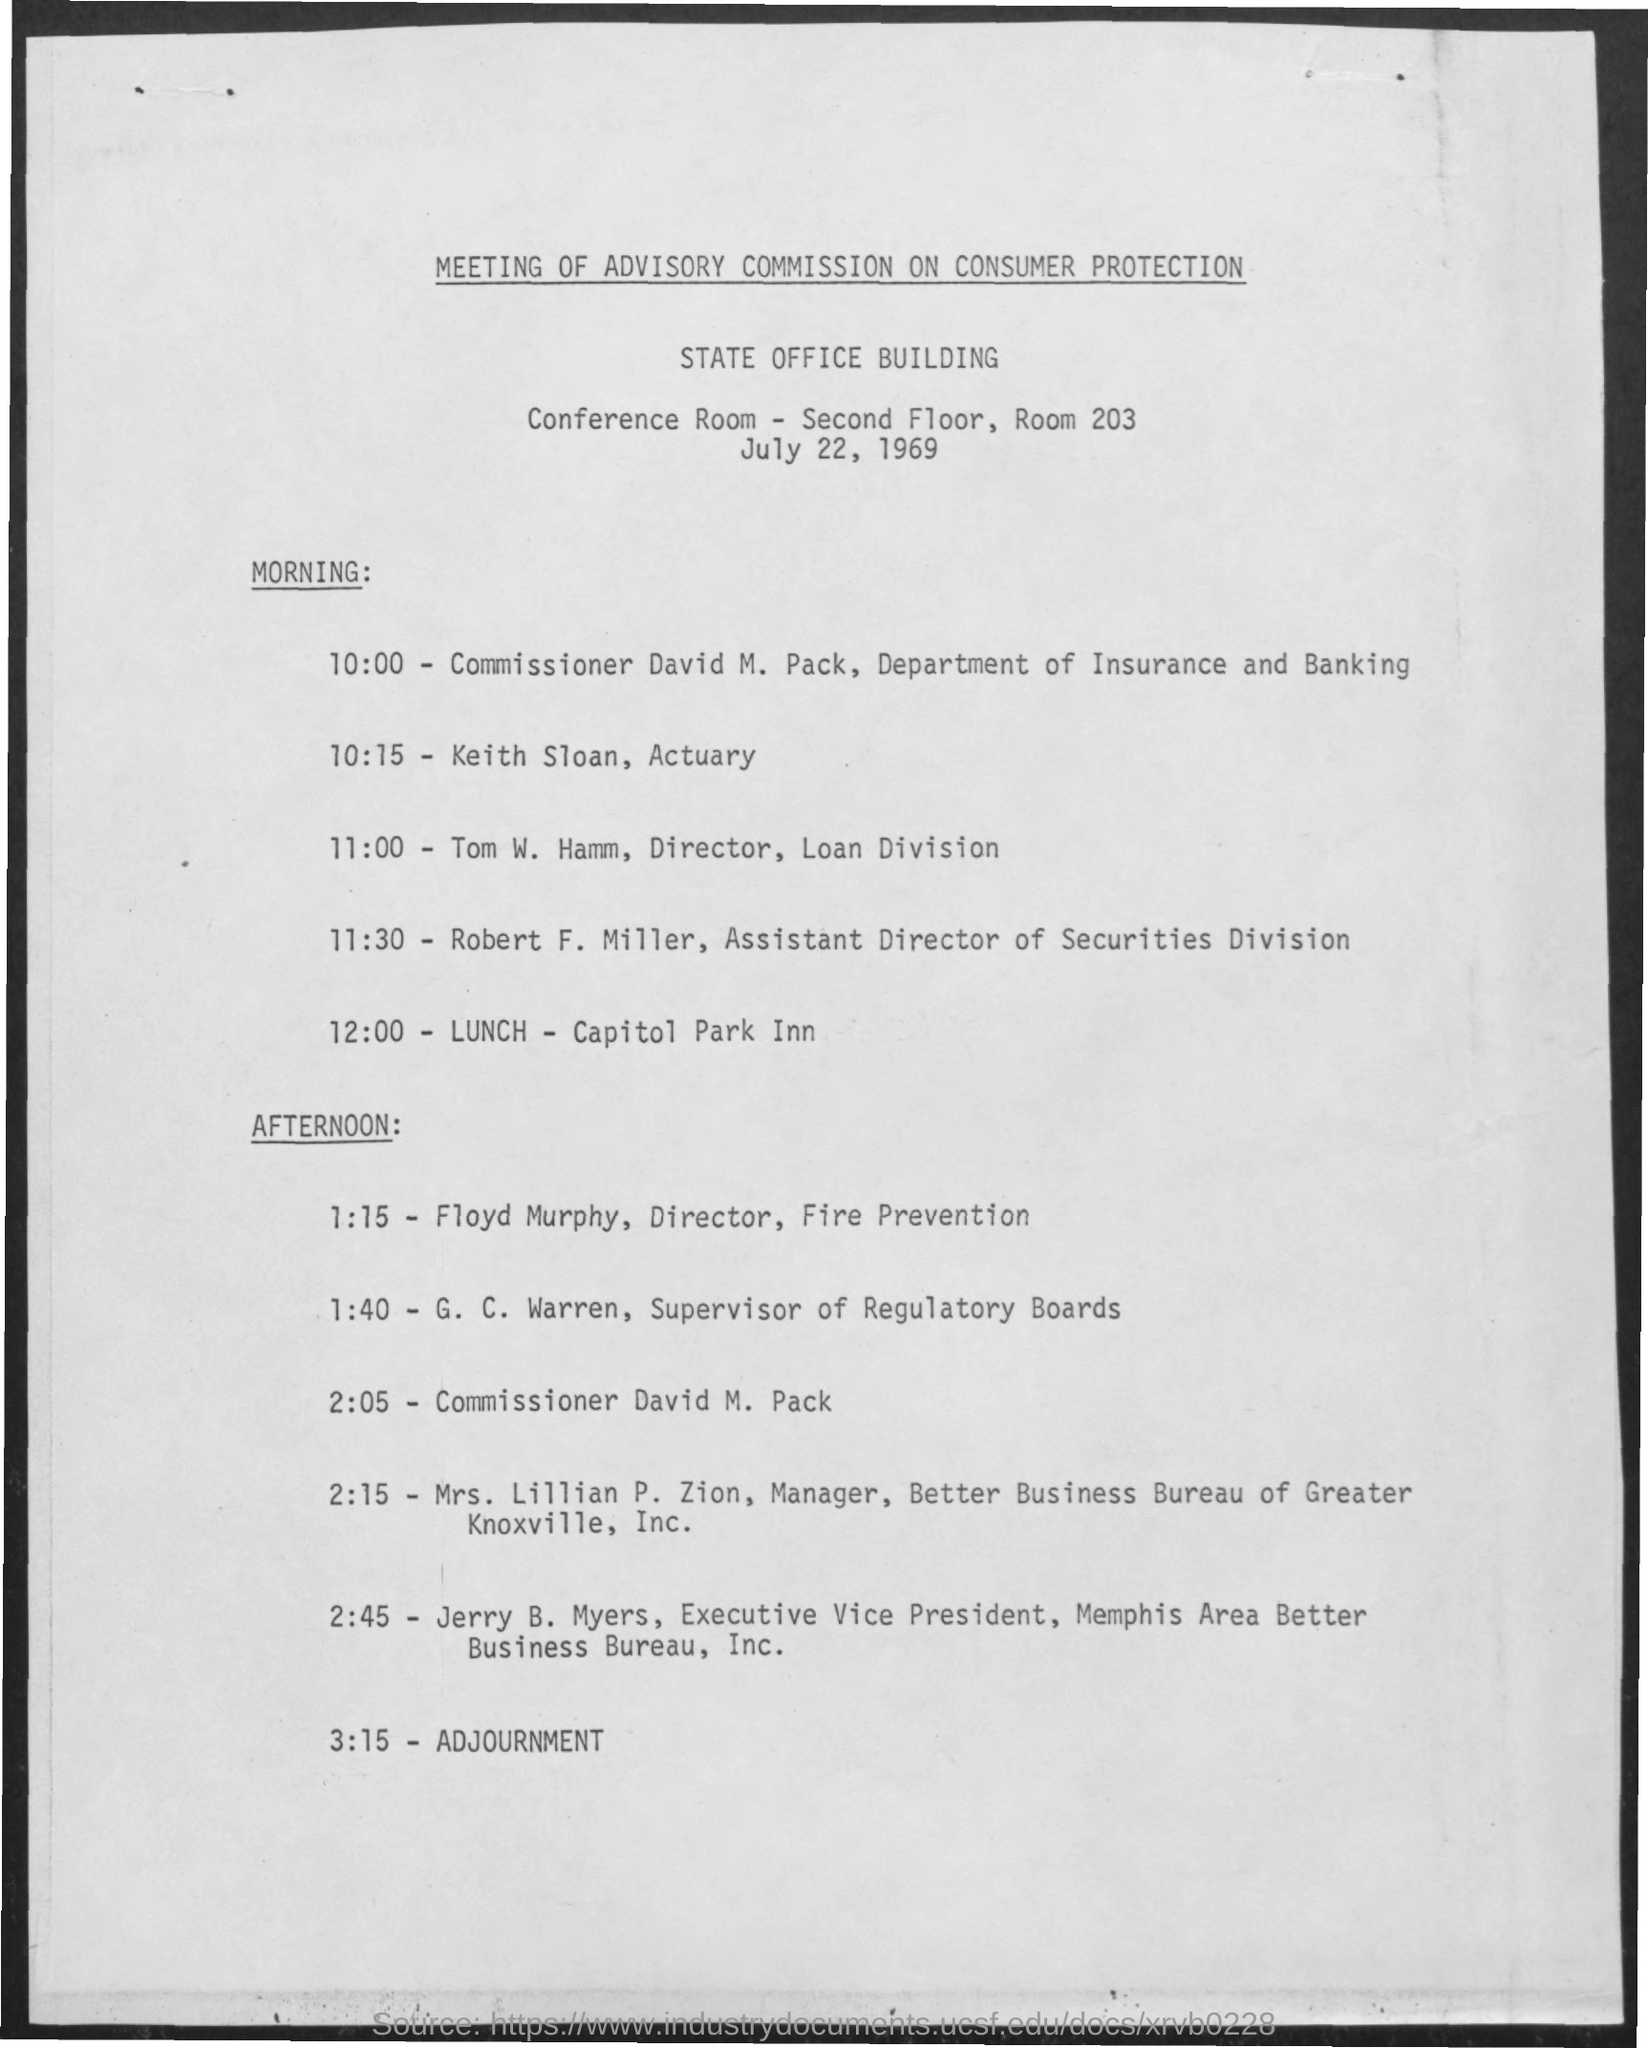what is the conference room no The conference is being held in Room 203, which is located on the second floor of the State Office Building, as mentioned in the schedule for the Advisory Commission on Consumer Protection meeting dated July 22, 1969. 